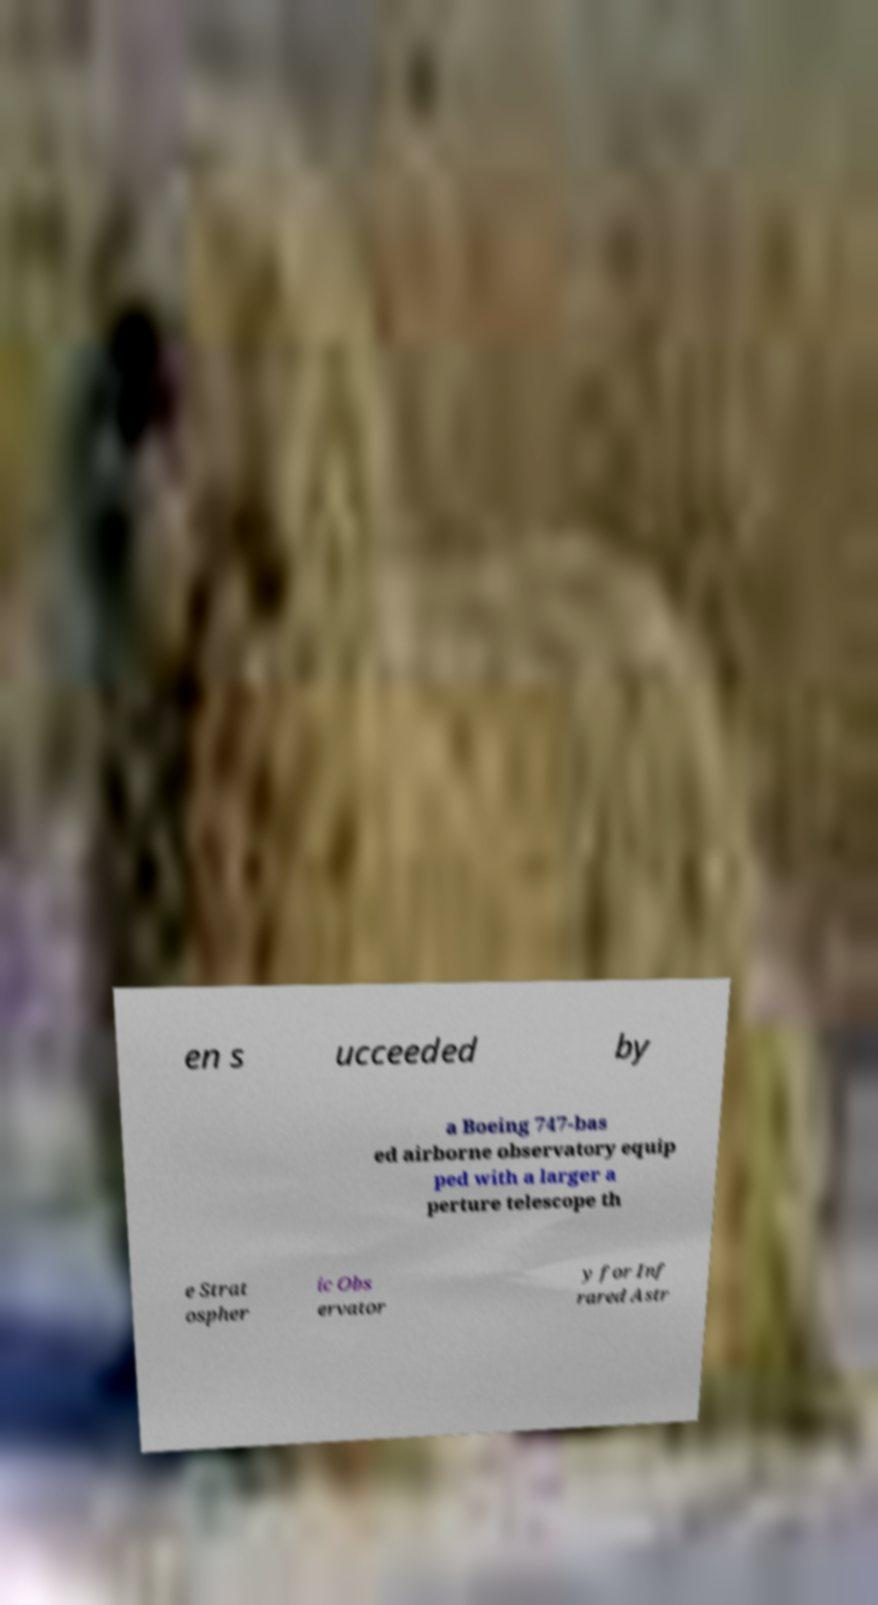Please read and relay the text visible in this image. What does it say? en s ucceeded by a Boeing 747-bas ed airborne observatory equip ped with a larger a perture telescope th e Strat ospher ic Obs ervator y for Inf rared Astr 